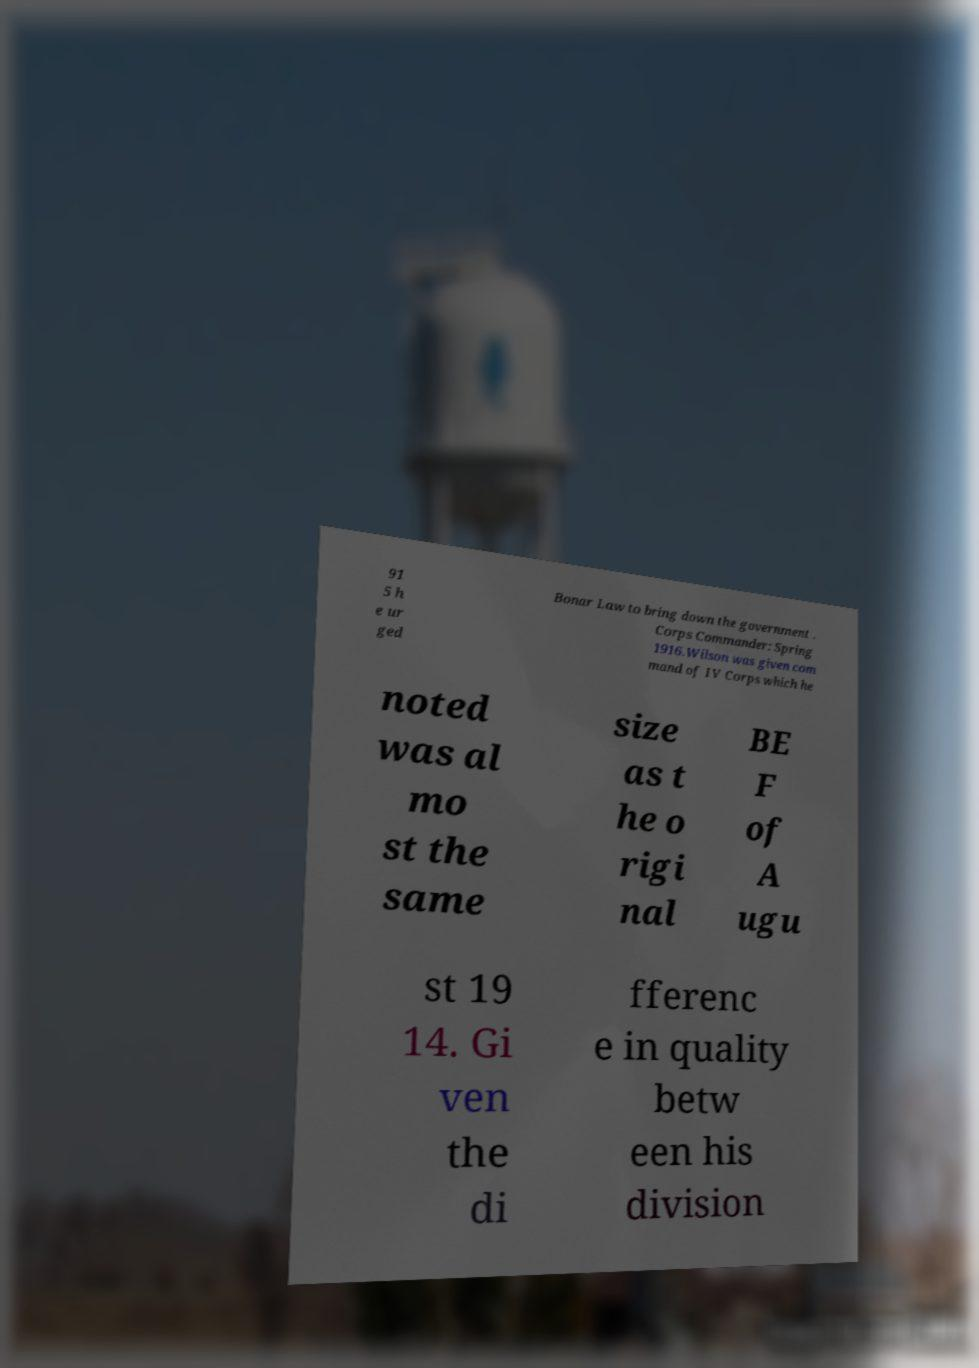There's text embedded in this image that I need extracted. Can you transcribe it verbatim? 91 5 h e ur ged Bonar Law to bring down the government . Corps Commander: Spring 1916.Wilson was given com mand of IV Corps which he noted was al mo st the same size as t he o rigi nal BE F of A ugu st 19 14. Gi ven the di fferenc e in quality betw een his division 